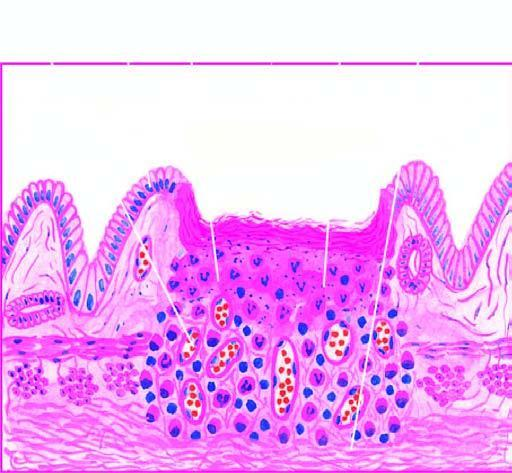what shows necrotic debris, ulceration and inflammation on the mucosal surface?
Answer the question using a single word or phrase. Photomicrograph on right 